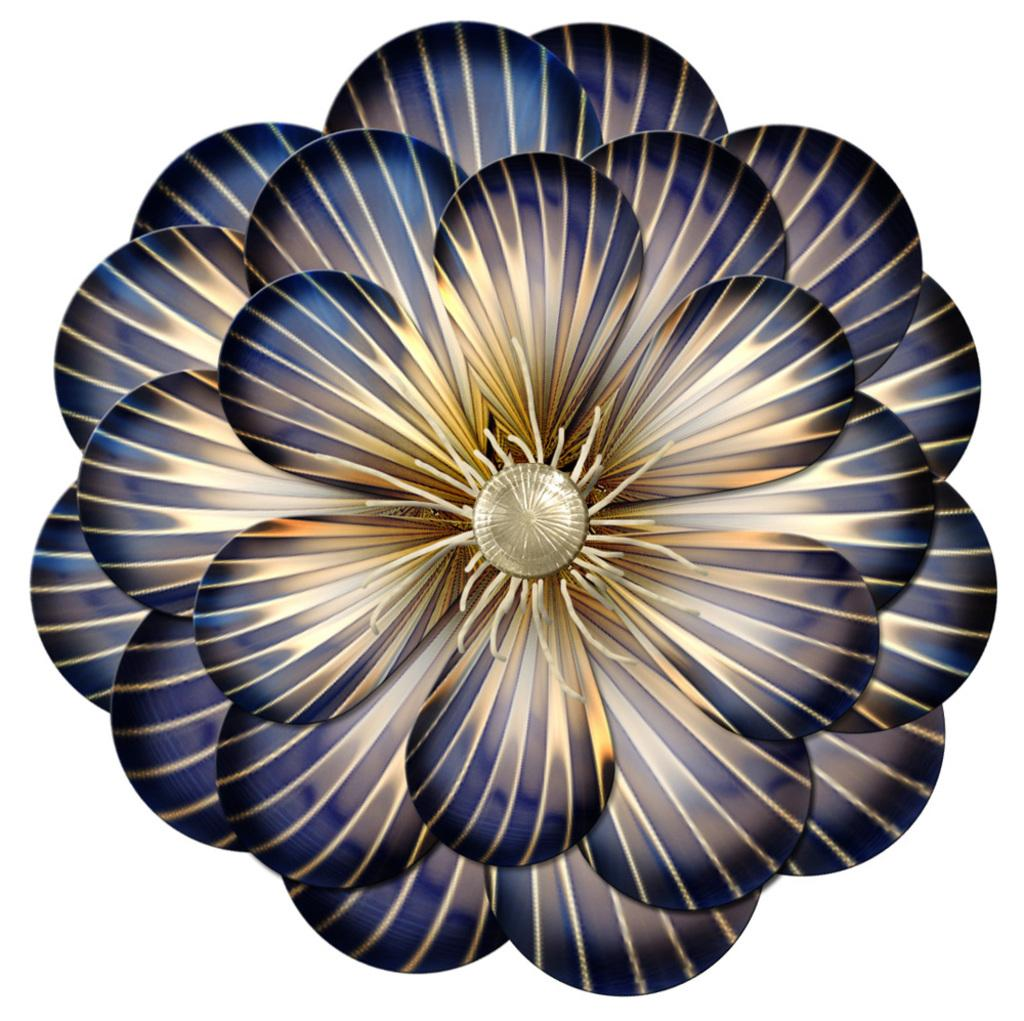What is the main subject of the picture? The main subject of the picture is an animated image of a flower. What type of star can be heard singing in the image? There is no star or singing present in the image; it features an animated image of a flower. What mark is visible on the petals of the flower in the image? There is no mark visible on the petals of the flower in the image; it is an animated image, and the details may not be as clear as in a photograph. 